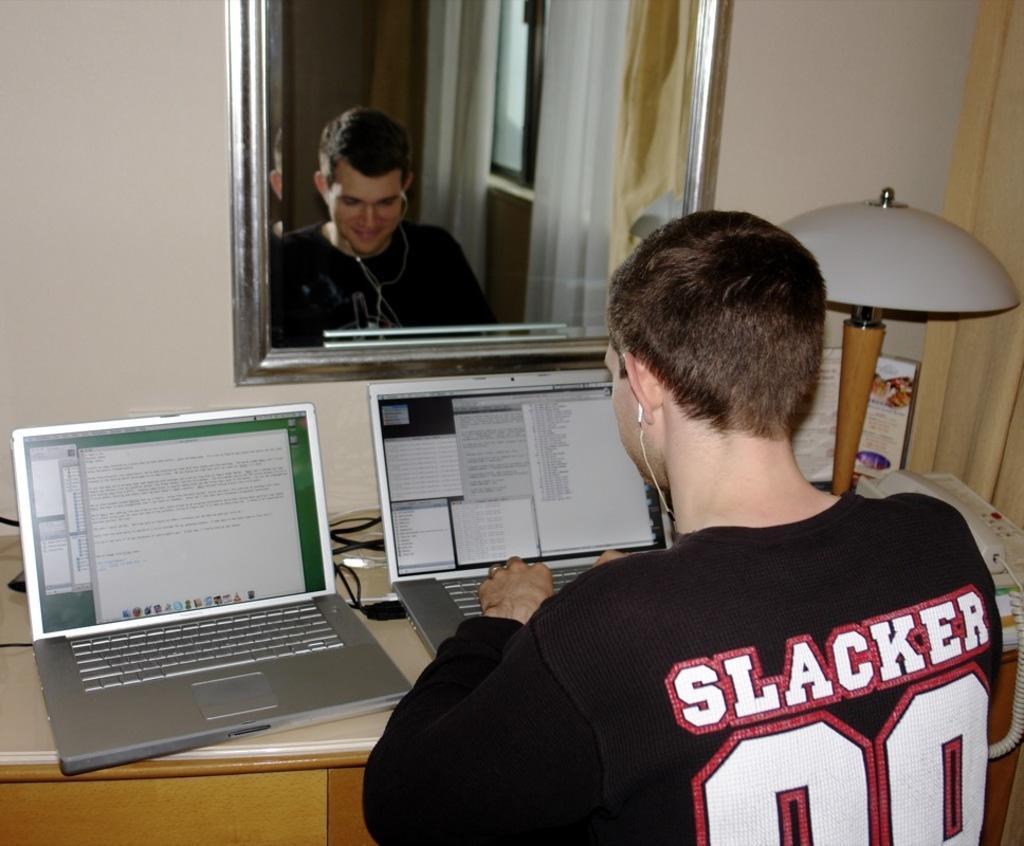Describe this image in one or two sentences. In the image there is a boy in front of laptop and beside the laptop there is another laptop,His image is reflected on the mirror and there is a lamp beside him,In the mirror we can see window with curtains. 